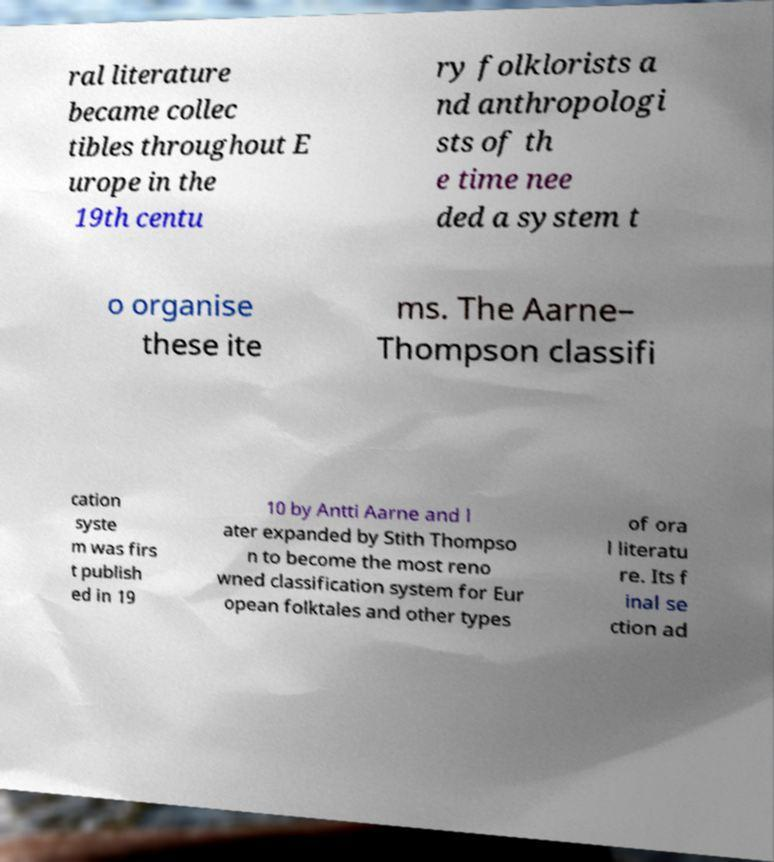Could you extract and type out the text from this image? ral literature became collec tibles throughout E urope in the 19th centu ry folklorists a nd anthropologi sts of th e time nee ded a system t o organise these ite ms. The Aarne– Thompson classifi cation syste m was firs t publish ed in 19 10 by Antti Aarne and l ater expanded by Stith Thompso n to become the most reno wned classification system for Eur opean folktales and other types of ora l literatu re. Its f inal se ction ad 